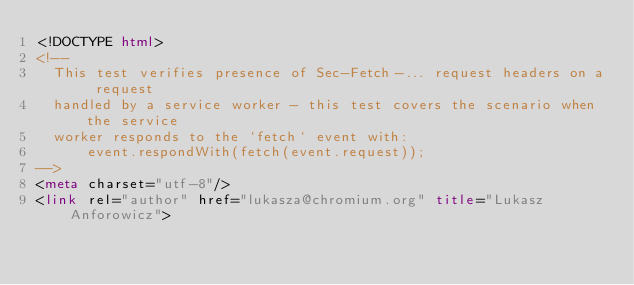<code> <loc_0><loc_0><loc_500><loc_500><_HTML_><!DOCTYPE html>
<!--
  This test verifies presence of Sec-Fetch-... request headers on a request
  handled by a service worker - this test covers the scenario when the service
  worker responds to the `fetch` event with:
      event.respondWith(fetch(event.request));
-->
<meta charset="utf-8"/>
<link rel="author" href="lukasza@chromium.org" title="Lukasz Anforowicz"></code> 